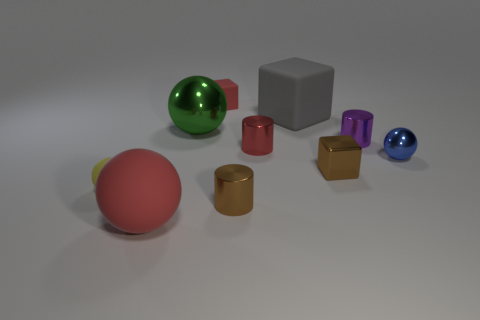Subtract all spheres. How many objects are left? 6 Add 2 tiny brown metal things. How many tiny brown metal things exist? 4 Subtract 1 green spheres. How many objects are left? 9 Subtract all large green shiny objects. Subtract all big red rubber things. How many objects are left? 8 Add 6 big metallic spheres. How many big metallic spheres are left? 7 